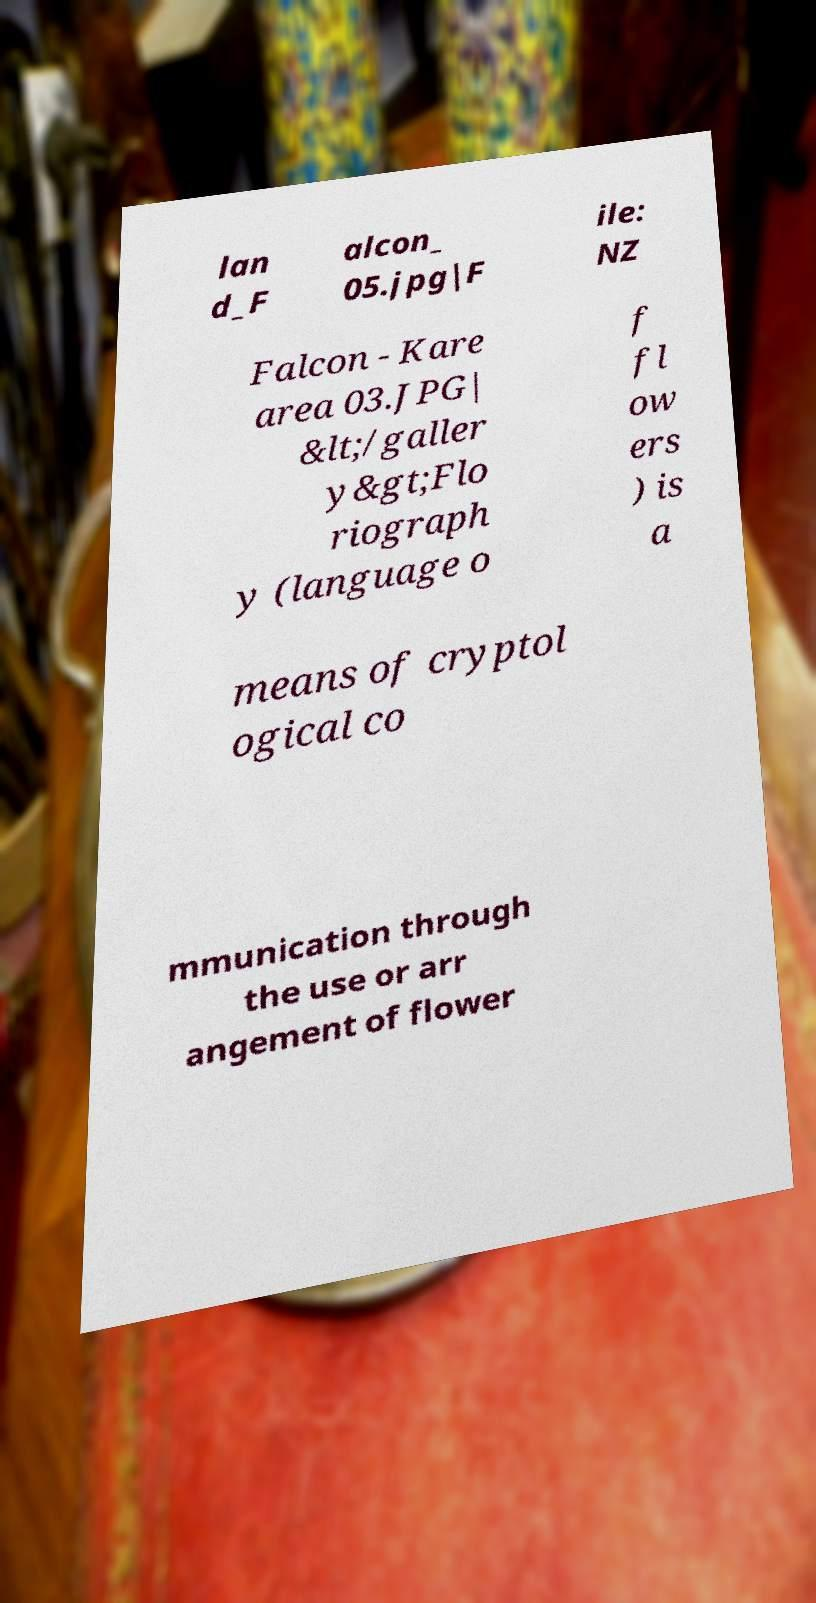Can you read and provide the text displayed in the image?This photo seems to have some interesting text. Can you extract and type it out for me? lan d_F alcon_ 05.jpg|F ile: NZ Falcon - Kare area 03.JPG| &lt;/galler y&gt;Flo riograph y (language o f fl ow ers ) is a means of cryptol ogical co mmunication through the use or arr angement of flower 